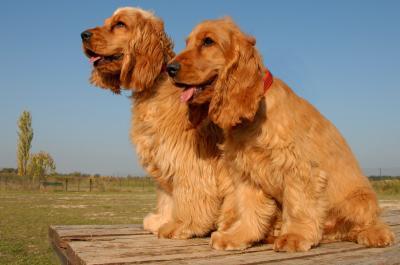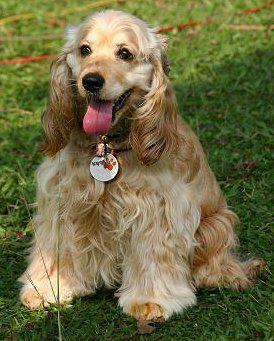The first image is the image on the left, the second image is the image on the right. Assess this claim about the two images: "One image has a colored background, while the other is white, they are not the same.". Correct or not? Answer yes or no. No. 